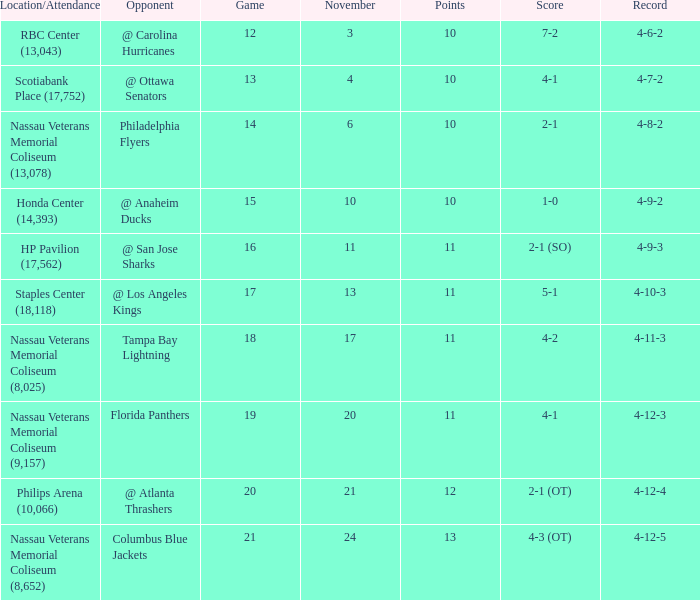What is the highest entry in November for the game 20? 21.0. 